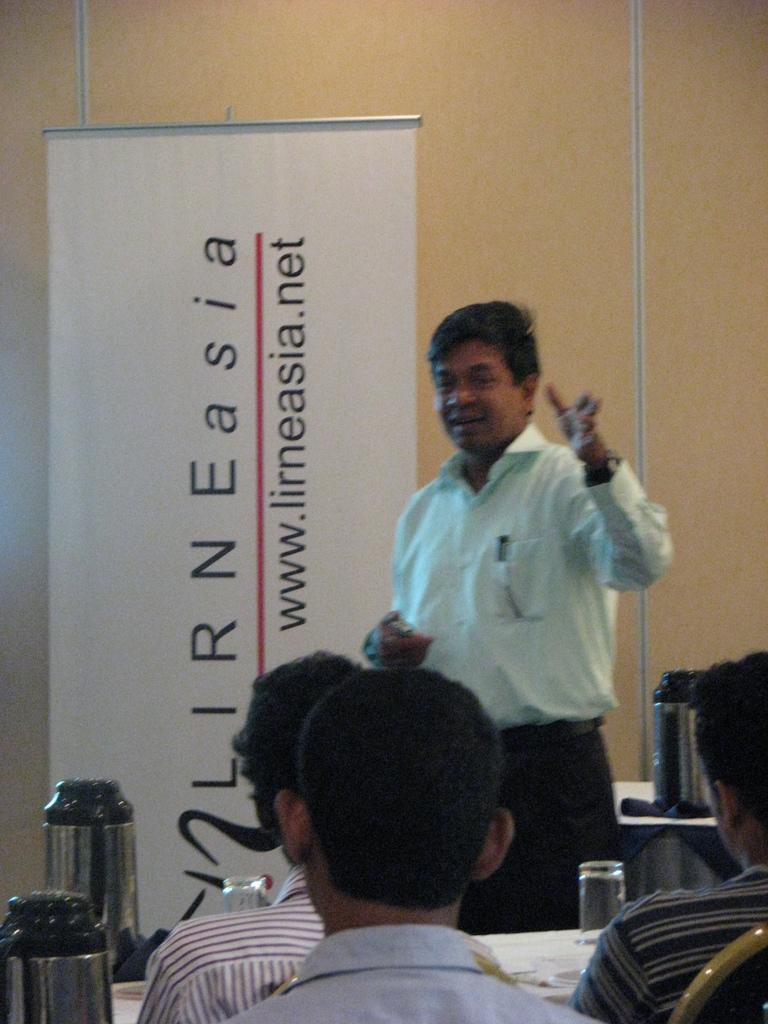What continent is mentioned in the web address?
Provide a short and direct response. Asia. 